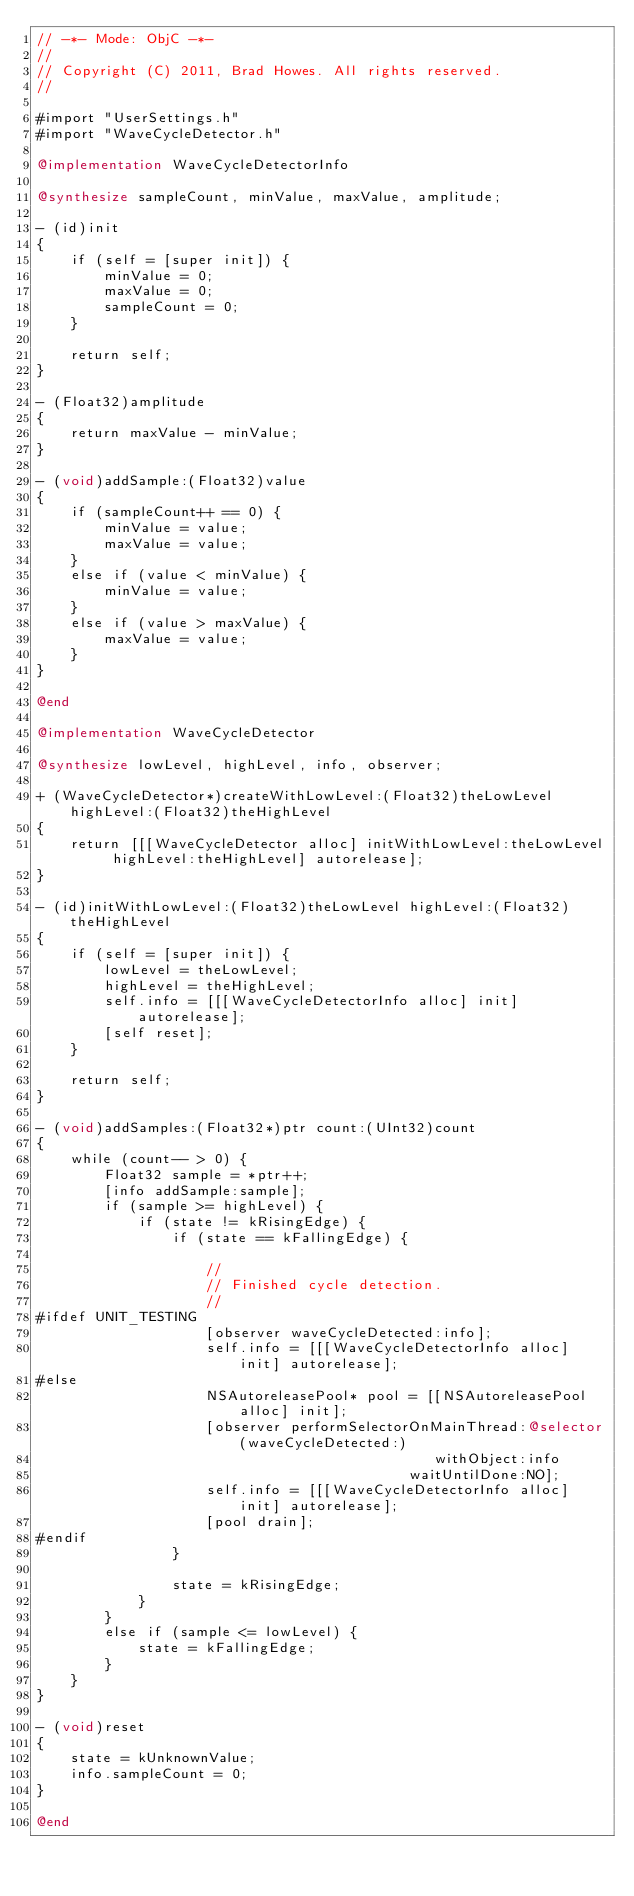<code> <loc_0><loc_0><loc_500><loc_500><_ObjectiveC_>// -*- Mode: ObjC -*-
//
// Copyright (C) 2011, Brad Howes. All rights reserved.
//

#import "UserSettings.h"
#import "WaveCycleDetector.h"

@implementation WaveCycleDetectorInfo

@synthesize sampleCount, minValue, maxValue, amplitude;

- (id)init
{
    if (self = [super init]) {
        minValue = 0;
        maxValue = 0;
        sampleCount = 0;
    }
    
    return self;
}

- (Float32)amplitude
{
    return maxValue - minValue;
}

- (void)addSample:(Float32)value
{
    if (sampleCount++ == 0) {
        minValue = value;
        maxValue = value;
    }
    else if (value < minValue) {
        minValue = value;
    }
    else if (value > maxValue) {
        maxValue = value;
    }
}

@end

@implementation WaveCycleDetector

@synthesize lowLevel, highLevel, info, observer;

+ (WaveCycleDetector*)createWithLowLevel:(Float32)theLowLevel highLevel:(Float32)theHighLevel
{
    return [[[WaveCycleDetector alloc] initWithLowLevel:theLowLevel highLevel:theHighLevel] autorelease];
}

- (id)initWithLowLevel:(Float32)theLowLevel highLevel:(Float32)theHighLevel
{
    if (self = [super init]) {
        lowLevel = theLowLevel;
        highLevel = theHighLevel;
        self.info = [[[WaveCycleDetectorInfo alloc] init] autorelease];
        [self reset];
    }
    
    return self;
}

- (void)addSamples:(Float32*)ptr count:(UInt32)count
{
    while (count-- > 0) {
        Float32 sample = *ptr++;
        [info addSample:sample];
        if (sample >= highLevel) {
            if (state != kRisingEdge) {
                if (state == kFallingEdge) {
                    
                    //
                    // Finished cycle detection.
                    //
#ifdef UNIT_TESTING
                    [observer waveCycleDetected:info];
                    self.info = [[[WaveCycleDetectorInfo alloc] init] autorelease];
#else
                    NSAutoreleasePool* pool = [[NSAutoreleasePool alloc] init];
                    [observer performSelectorOnMainThread:@selector(waveCycleDetected:)
                                               withObject:info
                                            waitUntilDone:NO];
                    self.info = [[[WaveCycleDetectorInfo alloc] init] autorelease];
                    [pool drain];
#endif
                }
                
                state = kRisingEdge;
            }
        }
        else if (sample <= lowLevel) {
            state = kFallingEdge;
        }
    }
}

- (void)reset
{
    state = kUnknownValue;
    info.sampleCount = 0;
}

@end
</code> 